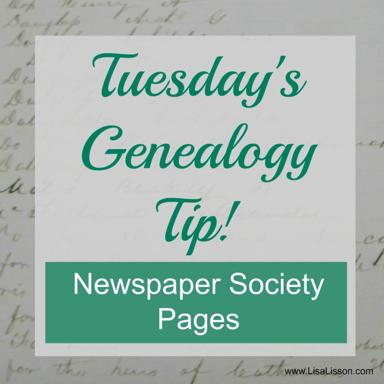What additional resources would you recommend for someone starting their genealogical research? For those beginning their genealogical journey, aside from society pages, I recommend visiting local libraries for archival records, consulting census data, and potentially engaging with DNA testing services to uncover ancestral links and build a comprehensive family tree. 